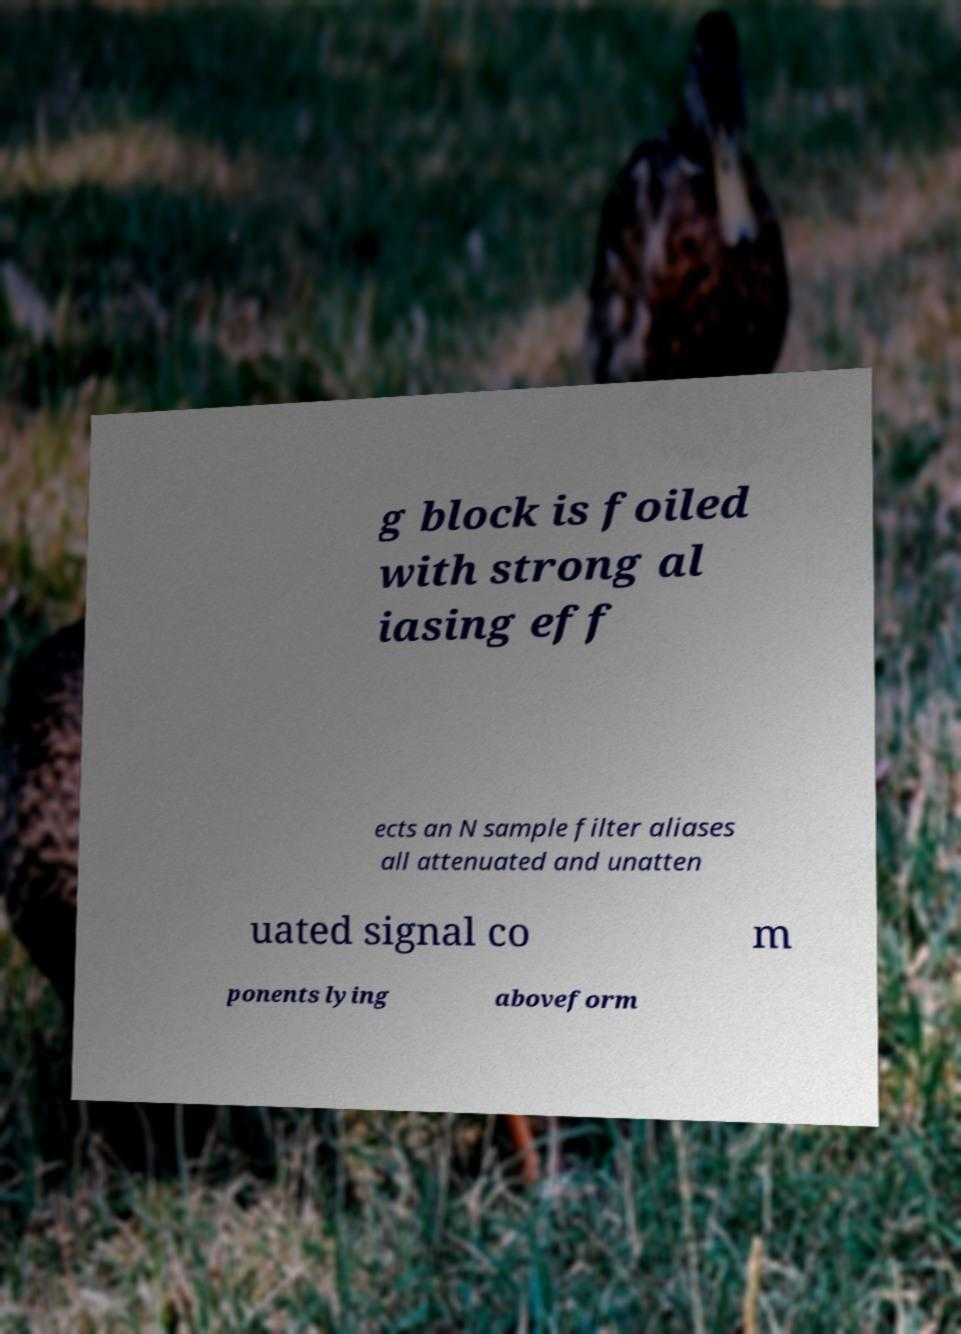For documentation purposes, I need the text within this image transcribed. Could you provide that? g block is foiled with strong al iasing eff ects an N sample filter aliases all attenuated and unatten uated signal co m ponents lying aboveform 